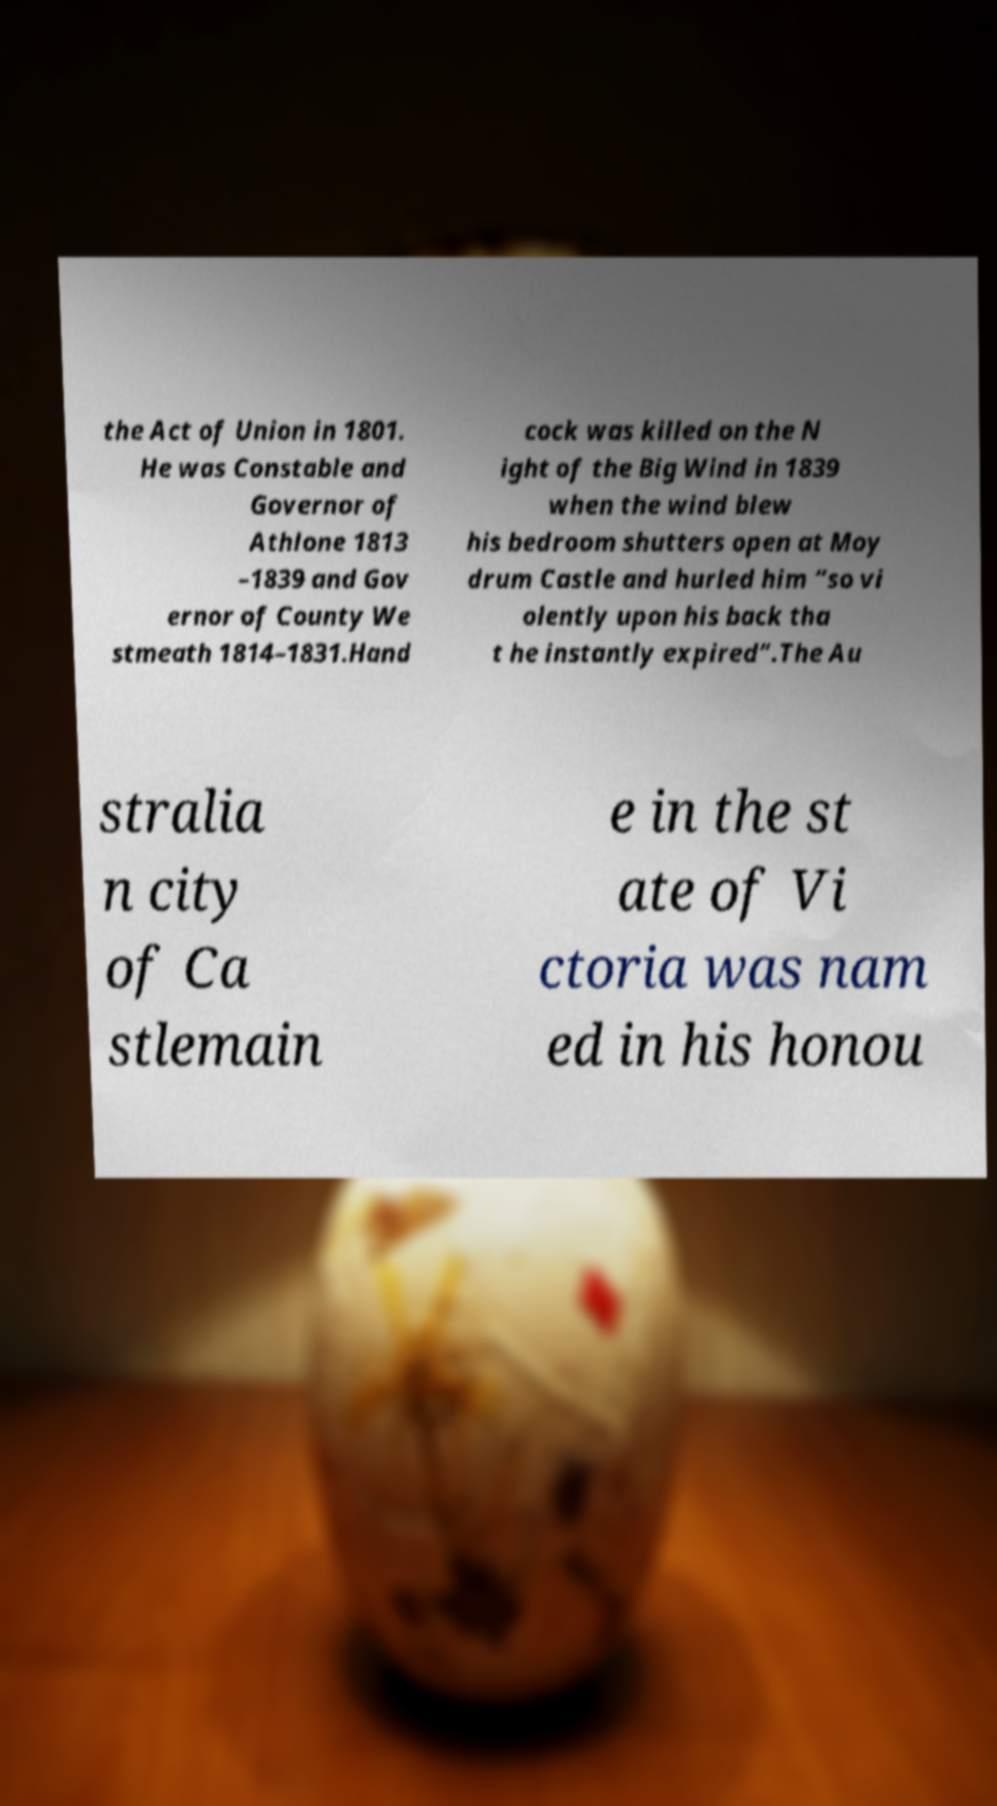Could you extract and type out the text from this image? the Act of Union in 1801. He was Constable and Governor of Athlone 1813 –1839 and Gov ernor of County We stmeath 1814–1831.Hand cock was killed on the N ight of the Big Wind in 1839 when the wind blew his bedroom shutters open at Moy drum Castle and hurled him “so vi olently upon his back tha t he instantly expired”.The Au stralia n city of Ca stlemain e in the st ate of Vi ctoria was nam ed in his honou 